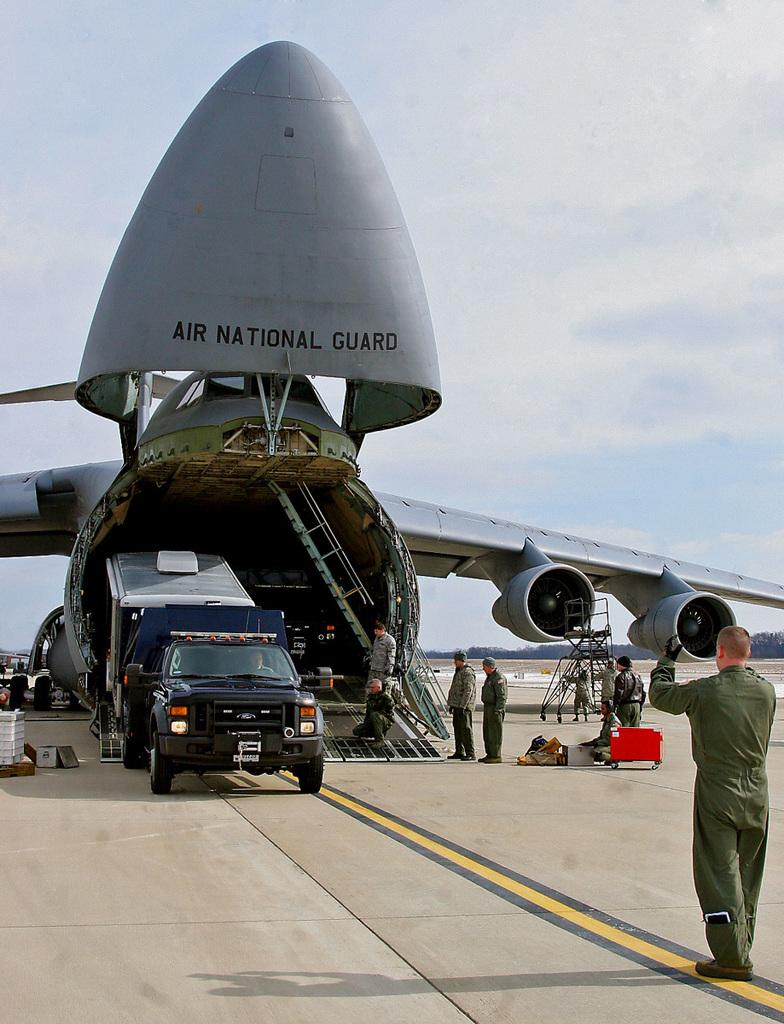<image>
Present a compact description of the photo's key features. A truck and trailer are coming down the ramp from a national guard plane. 